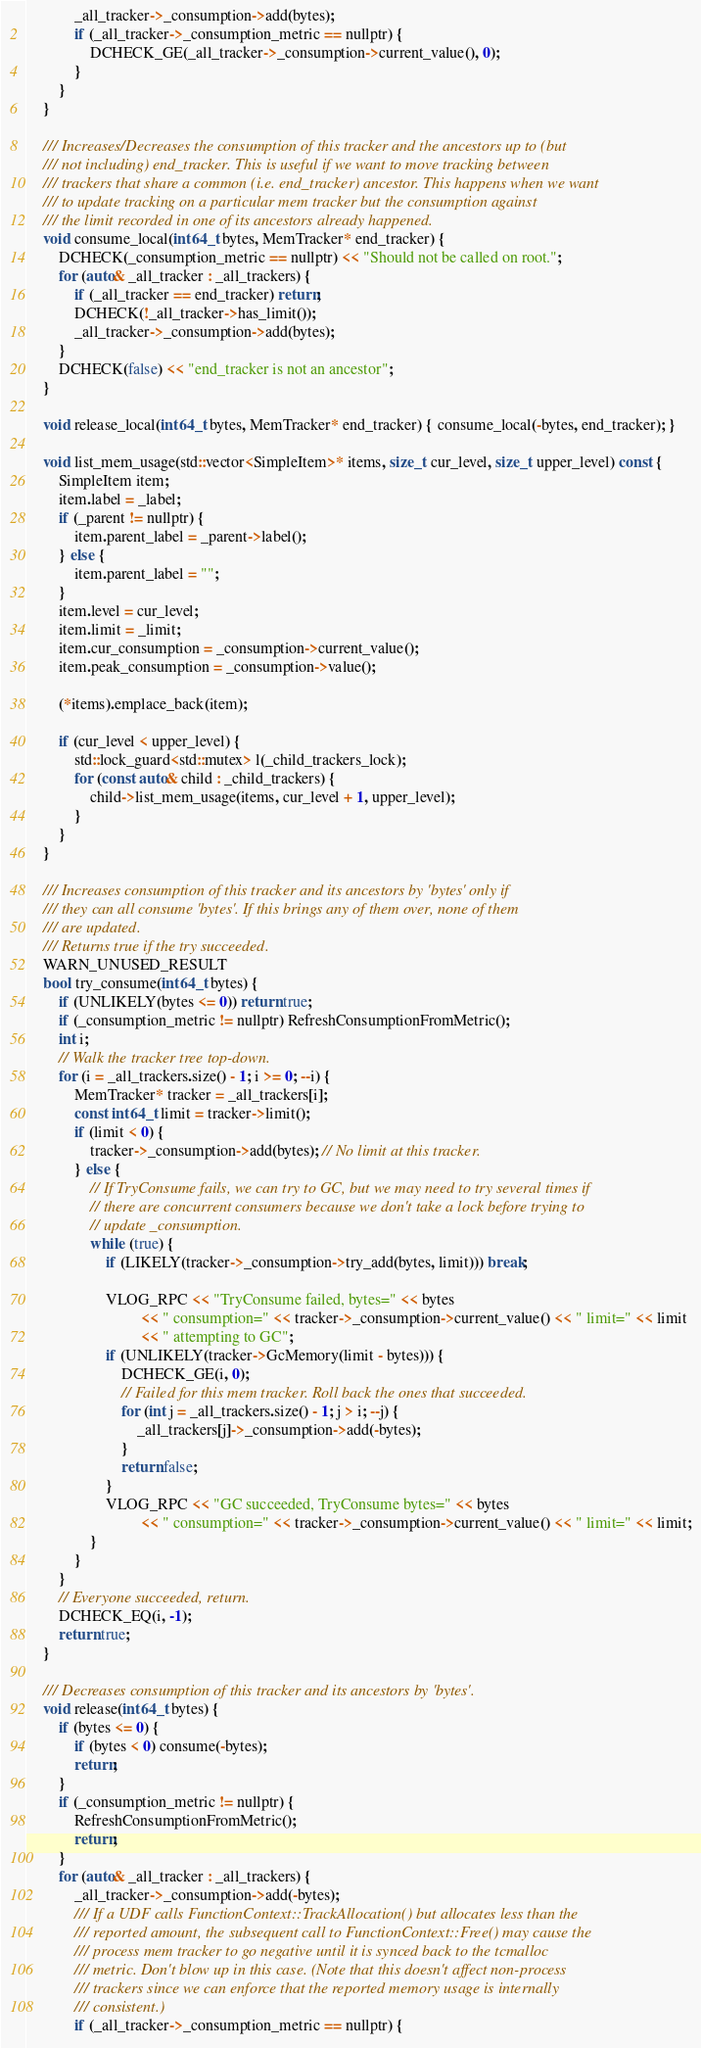Convert code to text. <code><loc_0><loc_0><loc_500><loc_500><_C_>            _all_tracker->_consumption->add(bytes);
            if (_all_tracker->_consumption_metric == nullptr) {
                DCHECK_GE(_all_tracker->_consumption->current_value(), 0);
            }
        }
    }

    /// Increases/Decreases the consumption of this tracker and the ancestors up to (but
    /// not including) end_tracker. This is useful if we want to move tracking between
    /// trackers that share a common (i.e. end_tracker) ancestor. This happens when we want
    /// to update tracking on a particular mem tracker but the consumption against
    /// the limit recorded in one of its ancestors already happened.
    void consume_local(int64_t bytes, MemTracker* end_tracker) {
        DCHECK(_consumption_metric == nullptr) << "Should not be called on root.";
        for (auto& _all_tracker : _all_trackers) {
            if (_all_tracker == end_tracker) return;
            DCHECK(!_all_tracker->has_limit());
            _all_tracker->_consumption->add(bytes);
        }
        DCHECK(false) << "end_tracker is not an ancestor";
    }

    void release_local(int64_t bytes, MemTracker* end_tracker) { consume_local(-bytes, end_tracker); }

    void list_mem_usage(std::vector<SimpleItem>* items, size_t cur_level, size_t upper_level) const {
        SimpleItem item;
        item.label = _label;
        if (_parent != nullptr) {
            item.parent_label = _parent->label();
        } else {
            item.parent_label = "";
        }
        item.level = cur_level;
        item.limit = _limit;
        item.cur_consumption = _consumption->current_value();
        item.peak_consumption = _consumption->value();

        (*items).emplace_back(item);

        if (cur_level < upper_level) {
            std::lock_guard<std::mutex> l(_child_trackers_lock);
            for (const auto& child : _child_trackers) {
                child->list_mem_usage(items, cur_level + 1, upper_level);
            }
        }
    }

    /// Increases consumption of this tracker and its ancestors by 'bytes' only if
    /// they can all consume 'bytes'. If this brings any of them over, none of them
    /// are updated.
    /// Returns true if the try succeeded.
    WARN_UNUSED_RESULT
    bool try_consume(int64_t bytes) {
        if (UNLIKELY(bytes <= 0)) return true;
        if (_consumption_metric != nullptr) RefreshConsumptionFromMetric();
        int i;
        // Walk the tracker tree top-down.
        for (i = _all_trackers.size() - 1; i >= 0; --i) {
            MemTracker* tracker = _all_trackers[i];
            const int64_t limit = tracker->limit();
            if (limit < 0) {
                tracker->_consumption->add(bytes); // No limit at this tracker.
            } else {
                // If TryConsume fails, we can try to GC, but we may need to try several times if
                // there are concurrent consumers because we don't take a lock before trying to
                // update _consumption.
                while (true) {
                    if (LIKELY(tracker->_consumption->try_add(bytes, limit))) break;

                    VLOG_RPC << "TryConsume failed, bytes=" << bytes
                             << " consumption=" << tracker->_consumption->current_value() << " limit=" << limit
                             << " attempting to GC";
                    if (UNLIKELY(tracker->GcMemory(limit - bytes))) {
                        DCHECK_GE(i, 0);
                        // Failed for this mem tracker. Roll back the ones that succeeded.
                        for (int j = _all_trackers.size() - 1; j > i; --j) {
                            _all_trackers[j]->_consumption->add(-bytes);
                        }
                        return false;
                    }
                    VLOG_RPC << "GC succeeded, TryConsume bytes=" << bytes
                             << " consumption=" << tracker->_consumption->current_value() << " limit=" << limit;
                }
            }
        }
        // Everyone succeeded, return.
        DCHECK_EQ(i, -1);
        return true;
    }

    /// Decreases consumption of this tracker and its ancestors by 'bytes'.
    void release(int64_t bytes) {
        if (bytes <= 0) {
            if (bytes < 0) consume(-bytes);
            return;
        }
        if (_consumption_metric != nullptr) {
            RefreshConsumptionFromMetric();
            return;
        }
        for (auto& _all_tracker : _all_trackers) {
            _all_tracker->_consumption->add(-bytes);
            /// If a UDF calls FunctionContext::TrackAllocation() but allocates less than the
            /// reported amount, the subsequent call to FunctionContext::Free() may cause the
            /// process mem tracker to go negative until it is synced back to the tcmalloc
            /// metric. Don't blow up in this case. (Note that this doesn't affect non-process
            /// trackers since we can enforce that the reported memory usage is internally
            /// consistent.)
            if (_all_tracker->_consumption_metric == nullptr) {</code> 